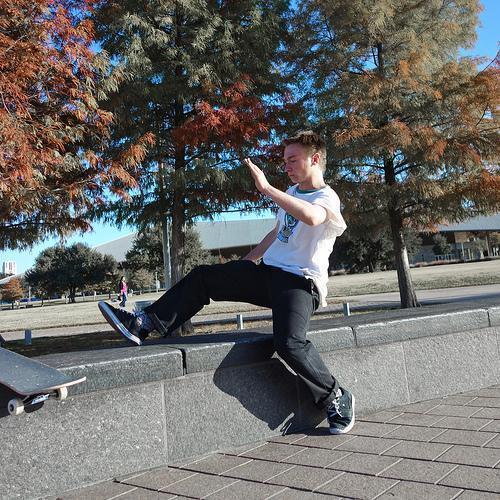How many people are there?
Give a very brief answer. 1. 